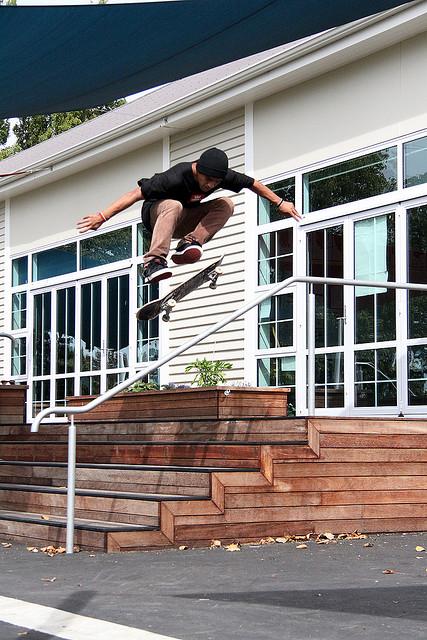Is this person wearing a hat?
Short answer required. Yes. What has this man been riding on?
Write a very short answer. Skateboard. What is the man doing?
Keep it brief. Skateboarding. 